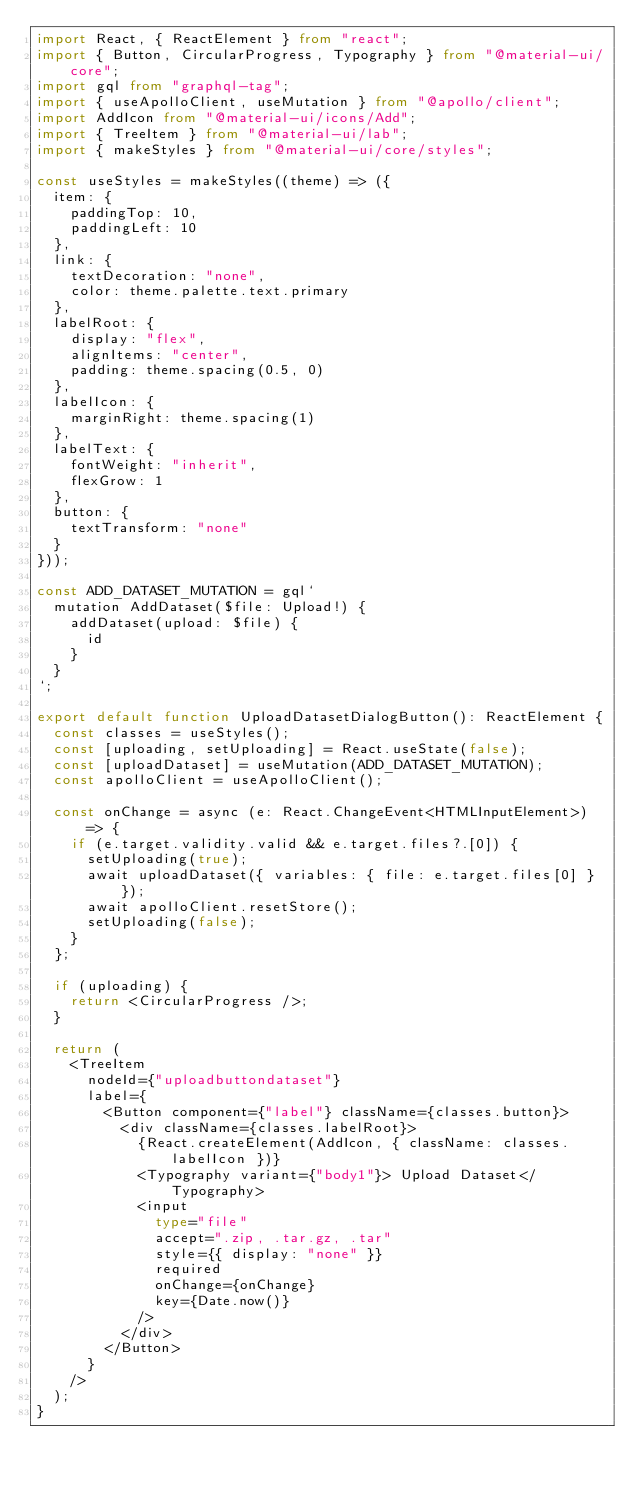Convert code to text. <code><loc_0><loc_0><loc_500><loc_500><_TypeScript_>import React, { ReactElement } from "react";
import { Button, CircularProgress, Typography } from "@material-ui/core";
import gql from "graphql-tag";
import { useApolloClient, useMutation } from "@apollo/client";
import AddIcon from "@material-ui/icons/Add";
import { TreeItem } from "@material-ui/lab";
import { makeStyles } from "@material-ui/core/styles";

const useStyles = makeStyles((theme) => ({
  item: {
    paddingTop: 10,
    paddingLeft: 10
  },
  link: {
    textDecoration: "none",
    color: theme.palette.text.primary
  },
  labelRoot: {
    display: "flex",
    alignItems: "center",
    padding: theme.spacing(0.5, 0)
  },
  labelIcon: {
    marginRight: theme.spacing(1)
  },
  labelText: {
    fontWeight: "inherit",
    flexGrow: 1
  },
  button: {
    textTransform: "none"
  }
}));

const ADD_DATASET_MUTATION = gql`
  mutation AddDataset($file: Upload!) {
    addDataset(upload: $file) {
      id
    }
  }
`;

export default function UploadDatasetDialogButton(): ReactElement {
  const classes = useStyles();
  const [uploading, setUploading] = React.useState(false);
  const [uploadDataset] = useMutation(ADD_DATASET_MUTATION);
  const apolloClient = useApolloClient();

  const onChange = async (e: React.ChangeEvent<HTMLInputElement>) => {
    if (e.target.validity.valid && e.target.files?.[0]) {
      setUploading(true);
      await uploadDataset({ variables: { file: e.target.files[0] } });
      await apolloClient.resetStore();
      setUploading(false);
    }
  };

  if (uploading) {
    return <CircularProgress />;
  }

  return (
    <TreeItem
      nodeId={"uploadbuttondataset"}
      label={
        <Button component={"label"} className={classes.button}>
          <div className={classes.labelRoot}>
            {React.createElement(AddIcon, { className: classes.labelIcon })}
            <Typography variant={"body1"}> Upload Dataset</Typography>
            <input
              type="file"
              accept=".zip, .tar.gz, .tar"
              style={{ display: "none" }}
              required
              onChange={onChange}
              key={Date.now()}
            />
          </div>
        </Button>
      }
    />
  );
}
</code> 